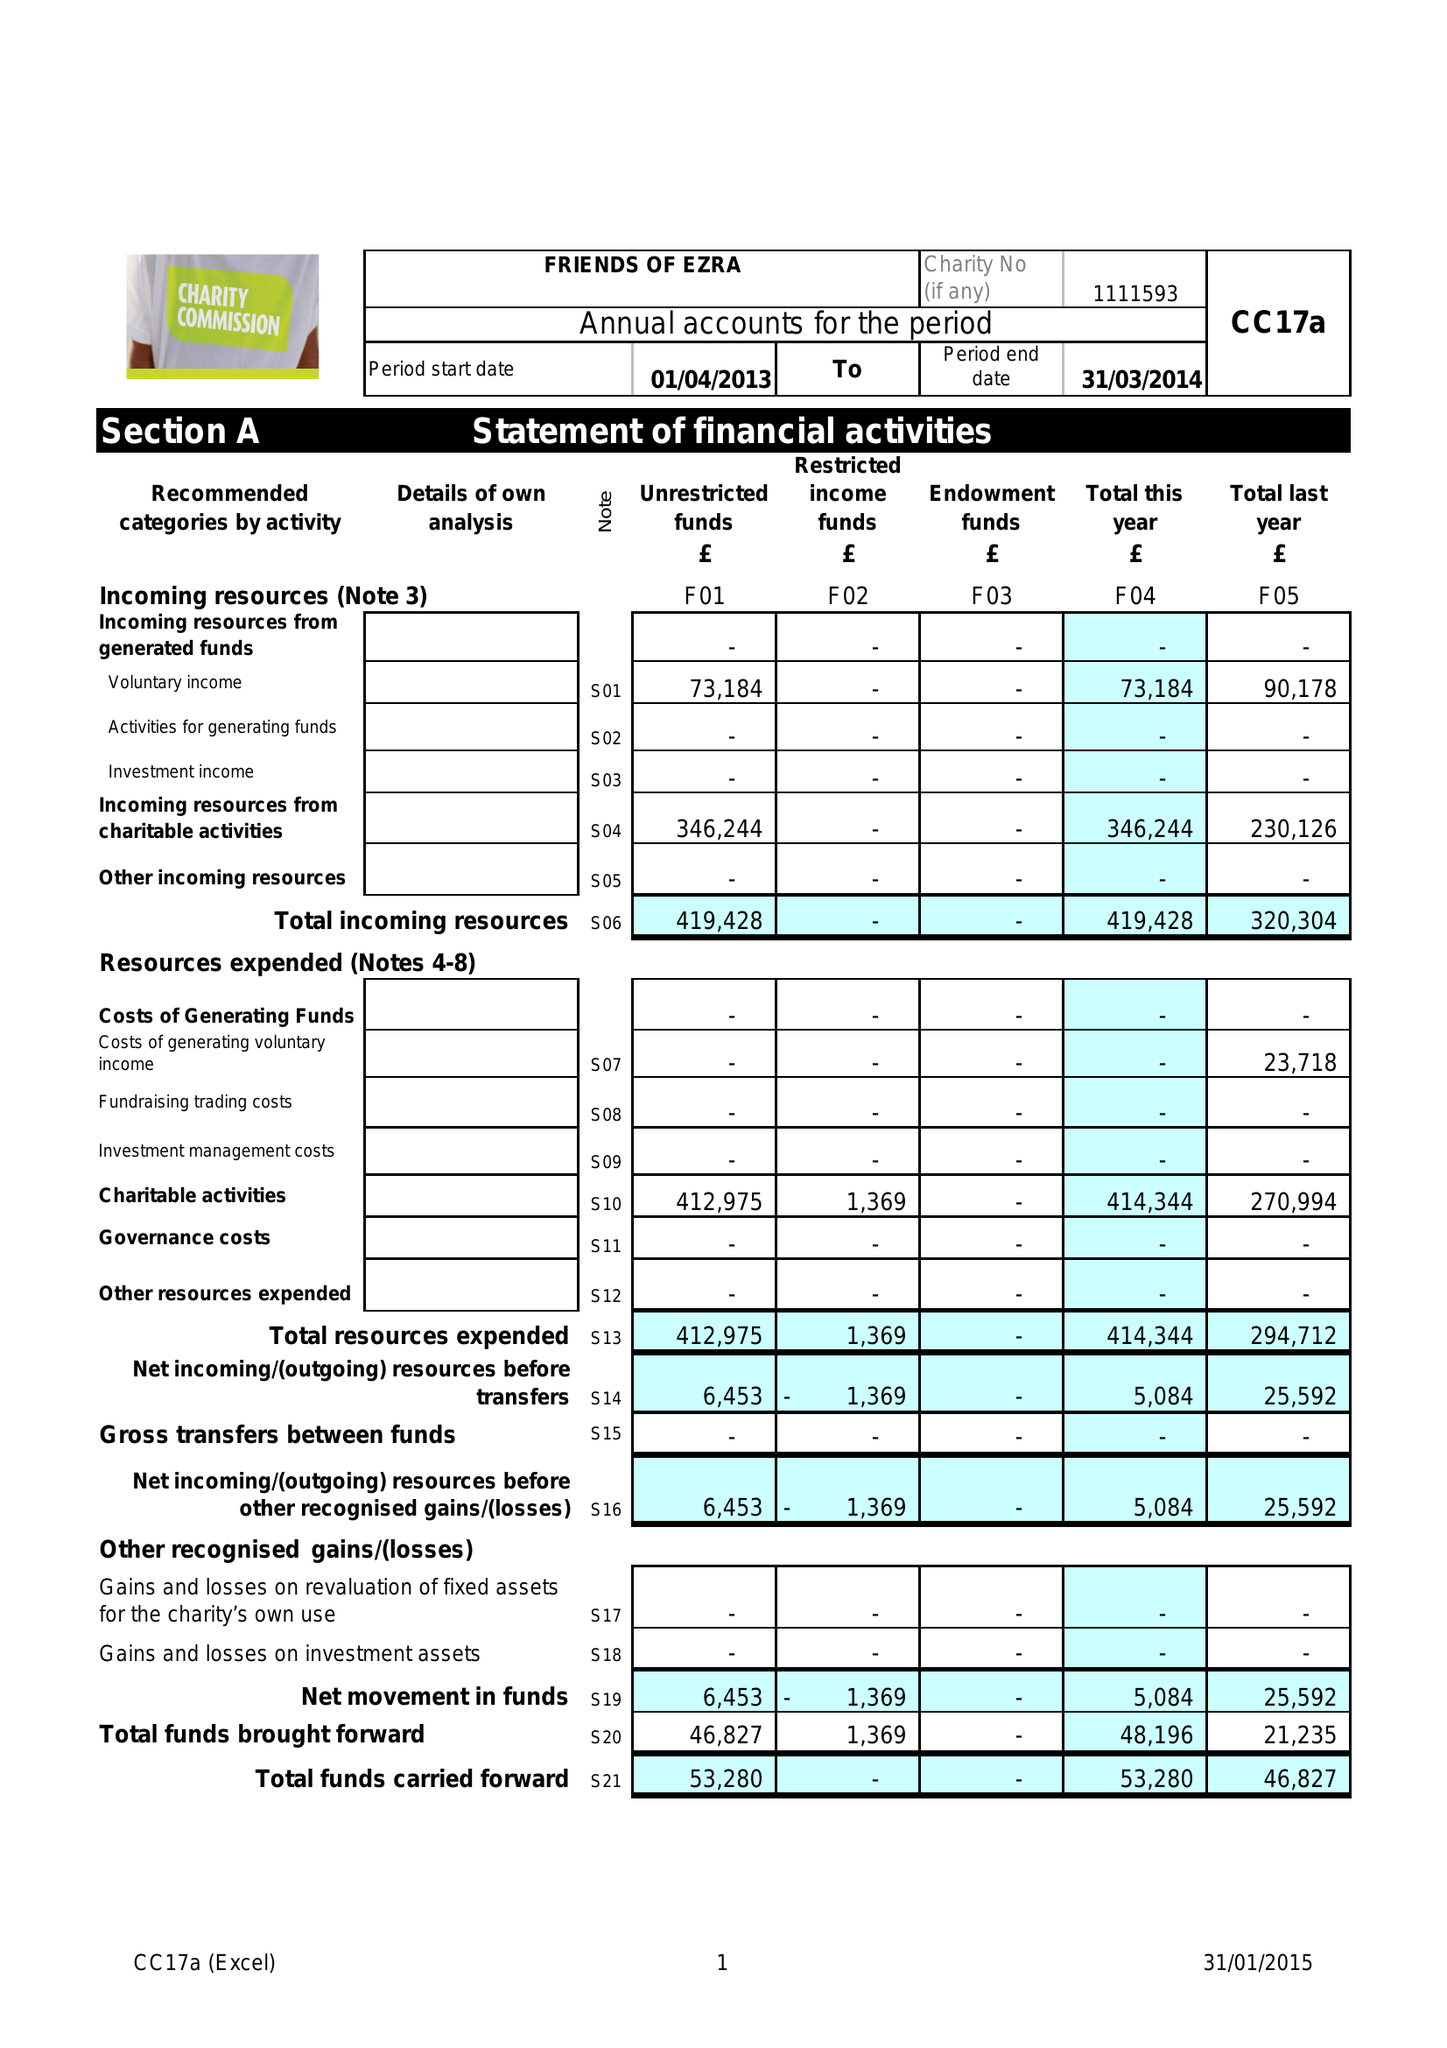What is the value for the charity_number?
Answer the question using a single word or phrase. 1111593 